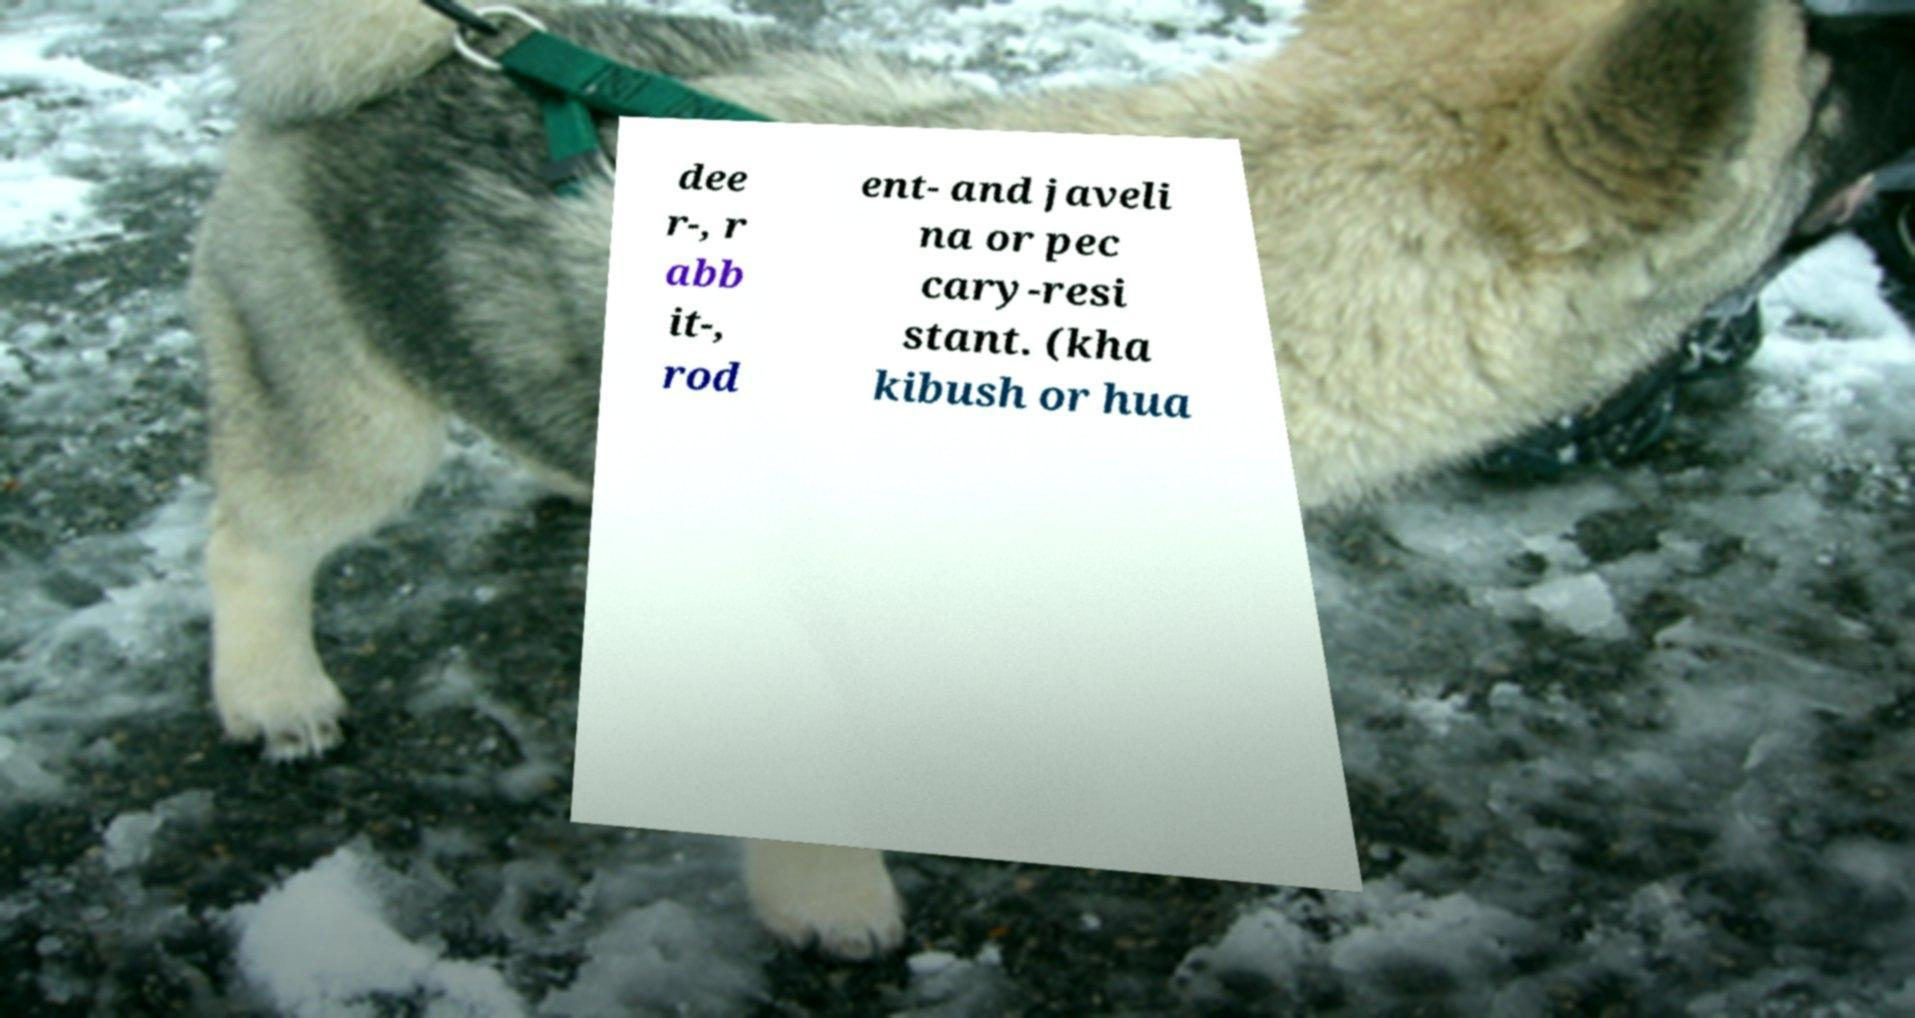Could you extract and type out the text from this image? dee r-, r abb it-, rod ent- and javeli na or pec cary-resi stant. (kha kibush or hua 